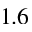Convert formula to latex. <formula><loc_0><loc_0><loc_500><loc_500>1 . 6</formula> 